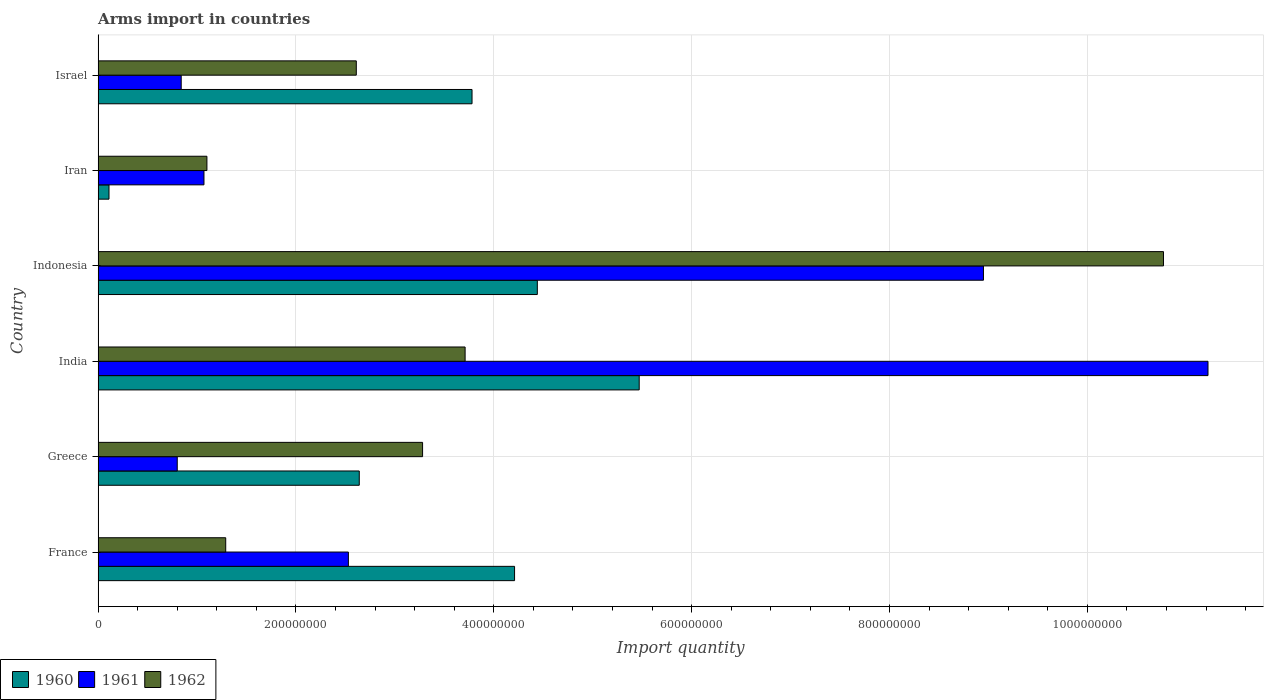How many groups of bars are there?
Offer a terse response. 6. Are the number of bars per tick equal to the number of legend labels?
Offer a very short reply. Yes. Are the number of bars on each tick of the Y-axis equal?
Your answer should be compact. Yes. How many bars are there on the 5th tick from the top?
Offer a very short reply. 3. How many bars are there on the 6th tick from the bottom?
Ensure brevity in your answer.  3. What is the label of the 3rd group of bars from the top?
Make the answer very short. Indonesia. What is the total arms import in 1960 in Israel?
Ensure brevity in your answer.  3.78e+08. Across all countries, what is the maximum total arms import in 1962?
Offer a very short reply. 1.08e+09. Across all countries, what is the minimum total arms import in 1960?
Your answer should be compact. 1.10e+07. In which country was the total arms import in 1960 minimum?
Give a very brief answer. Iran. What is the total total arms import in 1961 in the graph?
Provide a succinct answer. 2.54e+09. What is the difference between the total arms import in 1961 in Greece and that in India?
Ensure brevity in your answer.  -1.04e+09. What is the difference between the total arms import in 1962 in Israel and the total arms import in 1960 in India?
Make the answer very short. -2.86e+08. What is the average total arms import in 1961 per country?
Keep it short and to the point. 4.24e+08. What is the difference between the total arms import in 1960 and total arms import in 1961 in France?
Ensure brevity in your answer.  1.68e+08. In how many countries, is the total arms import in 1961 greater than 960000000 ?
Provide a short and direct response. 1. What is the ratio of the total arms import in 1961 in Greece to that in India?
Give a very brief answer. 0.07. Is the difference between the total arms import in 1960 in France and Israel greater than the difference between the total arms import in 1961 in France and Israel?
Offer a very short reply. No. What is the difference between the highest and the second highest total arms import in 1961?
Provide a short and direct response. 2.27e+08. What is the difference between the highest and the lowest total arms import in 1960?
Give a very brief answer. 5.36e+08. What does the 3rd bar from the top in Iran represents?
Your answer should be very brief. 1960. What does the 3rd bar from the bottom in Greece represents?
Your response must be concise. 1962. Is it the case that in every country, the sum of the total arms import in 1961 and total arms import in 1960 is greater than the total arms import in 1962?
Your answer should be very brief. Yes. How many countries are there in the graph?
Your response must be concise. 6. What is the difference between two consecutive major ticks on the X-axis?
Provide a short and direct response. 2.00e+08. Are the values on the major ticks of X-axis written in scientific E-notation?
Make the answer very short. No. Does the graph contain any zero values?
Ensure brevity in your answer.  No. Where does the legend appear in the graph?
Your answer should be very brief. Bottom left. How many legend labels are there?
Your answer should be compact. 3. How are the legend labels stacked?
Your response must be concise. Horizontal. What is the title of the graph?
Your response must be concise. Arms import in countries. What is the label or title of the X-axis?
Ensure brevity in your answer.  Import quantity. What is the Import quantity in 1960 in France?
Make the answer very short. 4.21e+08. What is the Import quantity in 1961 in France?
Give a very brief answer. 2.53e+08. What is the Import quantity of 1962 in France?
Your response must be concise. 1.29e+08. What is the Import quantity of 1960 in Greece?
Provide a short and direct response. 2.64e+08. What is the Import quantity in 1961 in Greece?
Ensure brevity in your answer.  8.00e+07. What is the Import quantity in 1962 in Greece?
Offer a very short reply. 3.28e+08. What is the Import quantity of 1960 in India?
Your answer should be very brief. 5.47e+08. What is the Import quantity in 1961 in India?
Offer a terse response. 1.12e+09. What is the Import quantity of 1962 in India?
Your response must be concise. 3.71e+08. What is the Import quantity of 1960 in Indonesia?
Ensure brevity in your answer.  4.44e+08. What is the Import quantity in 1961 in Indonesia?
Provide a short and direct response. 8.95e+08. What is the Import quantity of 1962 in Indonesia?
Make the answer very short. 1.08e+09. What is the Import quantity of 1960 in Iran?
Provide a succinct answer. 1.10e+07. What is the Import quantity of 1961 in Iran?
Your answer should be compact. 1.07e+08. What is the Import quantity in 1962 in Iran?
Make the answer very short. 1.10e+08. What is the Import quantity of 1960 in Israel?
Your answer should be very brief. 3.78e+08. What is the Import quantity of 1961 in Israel?
Ensure brevity in your answer.  8.40e+07. What is the Import quantity of 1962 in Israel?
Your answer should be compact. 2.61e+08. Across all countries, what is the maximum Import quantity in 1960?
Ensure brevity in your answer.  5.47e+08. Across all countries, what is the maximum Import quantity in 1961?
Provide a short and direct response. 1.12e+09. Across all countries, what is the maximum Import quantity in 1962?
Your answer should be very brief. 1.08e+09. Across all countries, what is the minimum Import quantity of 1960?
Your answer should be compact. 1.10e+07. Across all countries, what is the minimum Import quantity in 1961?
Give a very brief answer. 8.00e+07. Across all countries, what is the minimum Import quantity of 1962?
Your answer should be very brief. 1.10e+08. What is the total Import quantity in 1960 in the graph?
Your answer should be very brief. 2.06e+09. What is the total Import quantity of 1961 in the graph?
Provide a short and direct response. 2.54e+09. What is the total Import quantity in 1962 in the graph?
Make the answer very short. 2.28e+09. What is the difference between the Import quantity of 1960 in France and that in Greece?
Your response must be concise. 1.57e+08. What is the difference between the Import quantity in 1961 in France and that in Greece?
Offer a terse response. 1.73e+08. What is the difference between the Import quantity in 1962 in France and that in Greece?
Offer a terse response. -1.99e+08. What is the difference between the Import quantity in 1960 in France and that in India?
Keep it short and to the point. -1.26e+08. What is the difference between the Import quantity of 1961 in France and that in India?
Offer a very short reply. -8.69e+08. What is the difference between the Import quantity in 1962 in France and that in India?
Provide a short and direct response. -2.42e+08. What is the difference between the Import quantity in 1960 in France and that in Indonesia?
Provide a succinct answer. -2.30e+07. What is the difference between the Import quantity in 1961 in France and that in Indonesia?
Offer a terse response. -6.42e+08. What is the difference between the Import quantity in 1962 in France and that in Indonesia?
Keep it short and to the point. -9.48e+08. What is the difference between the Import quantity in 1960 in France and that in Iran?
Keep it short and to the point. 4.10e+08. What is the difference between the Import quantity in 1961 in France and that in Iran?
Provide a short and direct response. 1.46e+08. What is the difference between the Import quantity in 1962 in France and that in Iran?
Provide a short and direct response. 1.90e+07. What is the difference between the Import quantity of 1960 in France and that in Israel?
Your answer should be very brief. 4.30e+07. What is the difference between the Import quantity in 1961 in France and that in Israel?
Ensure brevity in your answer.  1.69e+08. What is the difference between the Import quantity in 1962 in France and that in Israel?
Ensure brevity in your answer.  -1.32e+08. What is the difference between the Import quantity in 1960 in Greece and that in India?
Keep it short and to the point. -2.83e+08. What is the difference between the Import quantity of 1961 in Greece and that in India?
Provide a succinct answer. -1.04e+09. What is the difference between the Import quantity of 1962 in Greece and that in India?
Your answer should be compact. -4.30e+07. What is the difference between the Import quantity in 1960 in Greece and that in Indonesia?
Provide a short and direct response. -1.80e+08. What is the difference between the Import quantity in 1961 in Greece and that in Indonesia?
Offer a terse response. -8.15e+08. What is the difference between the Import quantity in 1962 in Greece and that in Indonesia?
Offer a terse response. -7.49e+08. What is the difference between the Import quantity in 1960 in Greece and that in Iran?
Offer a terse response. 2.53e+08. What is the difference between the Import quantity in 1961 in Greece and that in Iran?
Offer a terse response. -2.70e+07. What is the difference between the Import quantity of 1962 in Greece and that in Iran?
Your answer should be very brief. 2.18e+08. What is the difference between the Import quantity in 1960 in Greece and that in Israel?
Keep it short and to the point. -1.14e+08. What is the difference between the Import quantity in 1961 in Greece and that in Israel?
Your response must be concise. -4.00e+06. What is the difference between the Import quantity of 1962 in Greece and that in Israel?
Provide a succinct answer. 6.70e+07. What is the difference between the Import quantity in 1960 in India and that in Indonesia?
Your answer should be compact. 1.03e+08. What is the difference between the Import quantity of 1961 in India and that in Indonesia?
Offer a very short reply. 2.27e+08. What is the difference between the Import quantity in 1962 in India and that in Indonesia?
Provide a succinct answer. -7.06e+08. What is the difference between the Import quantity in 1960 in India and that in Iran?
Your answer should be compact. 5.36e+08. What is the difference between the Import quantity in 1961 in India and that in Iran?
Provide a succinct answer. 1.02e+09. What is the difference between the Import quantity of 1962 in India and that in Iran?
Your response must be concise. 2.61e+08. What is the difference between the Import quantity in 1960 in India and that in Israel?
Offer a very short reply. 1.69e+08. What is the difference between the Import quantity in 1961 in India and that in Israel?
Ensure brevity in your answer.  1.04e+09. What is the difference between the Import quantity of 1962 in India and that in Israel?
Your answer should be very brief. 1.10e+08. What is the difference between the Import quantity of 1960 in Indonesia and that in Iran?
Provide a short and direct response. 4.33e+08. What is the difference between the Import quantity of 1961 in Indonesia and that in Iran?
Provide a succinct answer. 7.88e+08. What is the difference between the Import quantity of 1962 in Indonesia and that in Iran?
Provide a succinct answer. 9.67e+08. What is the difference between the Import quantity in 1960 in Indonesia and that in Israel?
Provide a succinct answer. 6.60e+07. What is the difference between the Import quantity of 1961 in Indonesia and that in Israel?
Provide a short and direct response. 8.11e+08. What is the difference between the Import quantity of 1962 in Indonesia and that in Israel?
Make the answer very short. 8.16e+08. What is the difference between the Import quantity of 1960 in Iran and that in Israel?
Ensure brevity in your answer.  -3.67e+08. What is the difference between the Import quantity in 1961 in Iran and that in Israel?
Your answer should be very brief. 2.30e+07. What is the difference between the Import quantity in 1962 in Iran and that in Israel?
Your answer should be compact. -1.51e+08. What is the difference between the Import quantity in 1960 in France and the Import quantity in 1961 in Greece?
Ensure brevity in your answer.  3.41e+08. What is the difference between the Import quantity in 1960 in France and the Import quantity in 1962 in Greece?
Offer a very short reply. 9.30e+07. What is the difference between the Import quantity of 1961 in France and the Import quantity of 1962 in Greece?
Ensure brevity in your answer.  -7.50e+07. What is the difference between the Import quantity of 1960 in France and the Import quantity of 1961 in India?
Give a very brief answer. -7.01e+08. What is the difference between the Import quantity of 1960 in France and the Import quantity of 1962 in India?
Keep it short and to the point. 5.00e+07. What is the difference between the Import quantity of 1961 in France and the Import quantity of 1962 in India?
Offer a terse response. -1.18e+08. What is the difference between the Import quantity of 1960 in France and the Import quantity of 1961 in Indonesia?
Provide a short and direct response. -4.74e+08. What is the difference between the Import quantity in 1960 in France and the Import quantity in 1962 in Indonesia?
Give a very brief answer. -6.56e+08. What is the difference between the Import quantity of 1961 in France and the Import quantity of 1962 in Indonesia?
Offer a terse response. -8.24e+08. What is the difference between the Import quantity of 1960 in France and the Import quantity of 1961 in Iran?
Provide a short and direct response. 3.14e+08. What is the difference between the Import quantity in 1960 in France and the Import quantity in 1962 in Iran?
Your response must be concise. 3.11e+08. What is the difference between the Import quantity in 1961 in France and the Import quantity in 1962 in Iran?
Your answer should be very brief. 1.43e+08. What is the difference between the Import quantity of 1960 in France and the Import quantity of 1961 in Israel?
Your response must be concise. 3.37e+08. What is the difference between the Import quantity in 1960 in France and the Import quantity in 1962 in Israel?
Your answer should be very brief. 1.60e+08. What is the difference between the Import quantity of 1961 in France and the Import quantity of 1962 in Israel?
Offer a terse response. -8.00e+06. What is the difference between the Import quantity in 1960 in Greece and the Import quantity in 1961 in India?
Give a very brief answer. -8.58e+08. What is the difference between the Import quantity of 1960 in Greece and the Import quantity of 1962 in India?
Keep it short and to the point. -1.07e+08. What is the difference between the Import quantity of 1961 in Greece and the Import quantity of 1962 in India?
Ensure brevity in your answer.  -2.91e+08. What is the difference between the Import quantity in 1960 in Greece and the Import quantity in 1961 in Indonesia?
Keep it short and to the point. -6.31e+08. What is the difference between the Import quantity of 1960 in Greece and the Import quantity of 1962 in Indonesia?
Give a very brief answer. -8.13e+08. What is the difference between the Import quantity in 1961 in Greece and the Import quantity in 1962 in Indonesia?
Provide a short and direct response. -9.97e+08. What is the difference between the Import quantity of 1960 in Greece and the Import quantity of 1961 in Iran?
Provide a succinct answer. 1.57e+08. What is the difference between the Import quantity of 1960 in Greece and the Import quantity of 1962 in Iran?
Your answer should be compact. 1.54e+08. What is the difference between the Import quantity of 1961 in Greece and the Import quantity of 1962 in Iran?
Your answer should be very brief. -3.00e+07. What is the difference between the Import quantity of 1960 in Greece and the Import quantity of 1961 in Israel?
Offer a very short reply. 1.80e+08. What is the difference between the Import quantity in 1961 in Greece and the Import quantity in 1962 in Israel?
Your answer should be compact. -1.81e+08. What is the difference between the Import quantity in 1960 in India and the Import quantity in 1961 in Indonesia?
Provide a succinct answer. -3.48e+08. What is the difference between the Import quantity in 1960 in India and the Import quantity in 1962 in Indonesia?
Keep it short and to the point. -5.30e+08. What is the difference between the Import quantity in 1961 in India and the Import quantity in 1962 in Indonesia?
Provide a short and direct response. 4.50e+07. What is the difference between the Import quantity of 1960 in India and the Import quantity of 1961 in Iran?
Ensure brevity in your answer.  4.40e+08. What is the difference between the Import quantity in 1960 in India and the Import quantity in 1962 in Iran?
Give a very brief answer. 4.37e+08. What is the difference between the Import quantity of 1961 in India and the Import quantity of 1962 in Iran?
Offer a very short reply. 1.01e+09. What is the difference between the Import quantity in 1960 in India and the Import quantity in 1961 in Israel?
Give a very brief answer. 4.63e+08. What is the difference between the Import quantity in 1960 in India and the Import quantity in 1962 in Israel?
Keep it short and to the point. 2.86e+08. What is the difference between the Import quantity in 1961 in India and the Import quantity in 1962 in Israel?
Provide a short and direct response. 8.61e+08. What is the difference between the Import quantity of 1960 in Indonesia and the Import quantity of 1961 in Iran?
Provide a succinct answer. 3.37e+08. What is the difference between the Import quantity in 1960 in Indonesia and the Import quantity in 1962 in Iran?
Ensure brevity in your answer.  3.34e+08. What is the difference between the Import quantity of 1961 in Indonesia and the Import quantity of 1962 in Iran?
Make the answer very short. 7.85e+08. What is the difference between the Import quantity of 1960 in Indonesia and the Import quantity of 1961 in Israel?
Ensure brevity in your answer.  3.60e+08. What is the difference between the Import quantity in 1960 in Indonesia and the Import quantity in 1962 in Israel?
Provide a short and direct response. 1.83e+08. What is the difference between the Import quantity in 1961 in Indonesia and the Import quantity in 1962 in Israel?
Keep it short and to the point. 6.34e+08. What is the difference between the Import quantity in 1960 in Iran and the Import quantity in 1961 in Israel?
Provide a short and direct response. -7.30e+07. What is the difference between the Import quantity in 1960 in Iran and the Import quantity in 1962 in Israel?
Your answer should be very brief. -2.50e+08. What is the difference between the Import quantity in 1961 in Iran and the Import quantity in 1962 in Israel?
Your answer should be compact. -1.54e+08. What is the average Import quantity in 1960 per country?
Your answer should be very brief. 3.44e+08. What is the average Import quantity in 1961 per country?
Ensure brevity in your answer.  4.24e+08. What is the average Import quantity in 1962 per country?
Provide a succinct answer. 3.79e+08. What is the difference between the Import quantity in 1960 and Import quantity in 1961 in France?
Your answer should be very brief. 1.68e+08. What is the difference between the Import quantity of 1960 and Import quantity of 1962 in France?
Make the answer very short. 2.92e+08. What is the difference between the Import quantity in 1961 and Import quantity in 1962 in France?
Offer a terse response. 1.24e+08. What is the difference between the Import quantity in 1960 and Import quantity in 1961 in Greece?
Offer a terse response. 1.84e+08. What is the difference between the Import quantity in 1960 and Import quantity in 1962 in Greece?
Make the answer very short. -6.40e+07. What is the difference between the Import quantity of 1961 and Import quantity of 1962 in Greece?
Give a very brief answer. -2.48e+08. What is the difference between the Import quantity in 1960 and Import quantity in 1961 in India?
Offer a terse response. -5.75e+08. What is the difference between the Import quantity in 1960 and Import quantity in 1962 in India?
Make the answer very short. 1.76e+08. What is the difference between the Import quantity in 1961 and Import quantity in 1962 in India?
Offer a very short reply. 7.51e+08. What is the difference between the Import quantity in 1960 and Import quantity in 1961 in Indonesia?
Make the answer very short. -4.51e+08. What is the difference between the Import quantity of 1960 and Import quantity of 1962 in Indonesia?
Make the answer very short. -6.33e+08. What is the difference between the Import quantity in 1961 and Import quantity in 1962 in Indonesia?
Offer a terse response. -1.82e+08. What is the difference between the Import quantity in 1960 and Import quantity in 1961 in Iran?
Make the answer very short. -9.60e+07. What is the difference between the Import quantity in 1960 and Import quantity in 1962 in Iran?
Make the answer very short. -9.90e+07. What is the difference between the Import quantity of 1961 and Import quantity of 1962 in Iran?
Your answer should be compact. -3.00e+06. What is the difference between the Import quantity in 1960 and Import quantity in 1961 in Israel?
Your answer should be very brief. 2.94e+08. What is the difference between the Import quantity in 1960 and Import quantity in 1962 in Israel?
Ensure brevity in your answer.  1.17e+08. What is the difference between the Import quantity of 1961 and Import quantity of 1962 in Israel?
Provide a short and direct response. -1.77e+08. What is the ratio of the Import quantity of 1960 in France to that in Greece?
Keep it short and to the point. 1.59. What is the ratio of the Import quantity in 1961 in France to that in Greece?
Your answer should be very brief. 3.16. What is the ratio of the Import quantity of 1962 in France to that in Greece?
Offer a terse response. 0.39. What is the ratio of the Import quantity of 1960 in France to that in India?
Provide a succinct answer. 0.77. What is the ratio of the Import quantity of 1961 in France to that in India?
Offer a terse response. 0.23. What is the ratio of the Import quantity of 1962 in France to that in India?
Offer a very short reply. 0.35. What is the ratio of the Import quantity of 1960 in France to that in Indonesia?
Give a very brief answer. 0.95. What is the ratio of the Import quantity of 1961 in France to that in Indonesia?
Your response must be concise. 0.28. What is the ratio of the Import quantity in 1962 in France to that in Indonesia?
Your response must be concise. 0.12. What is the ratio of the Import quantity of 1960 in France to that in Iran?
Your response must be concise. 38.27. What is the ratio of the Import quantity in 1961 in France to that in Iran?
Keep it short and to the point. 2.36. What is the ratio of the Import quantity of 1962 in France to that in Iran?
Make the answer very short. 1.17. What is the ratio of the Import quantity in 1960 in France to that in Israel?
Keep it short and to the point. 1.11. What is the ratio of the Import quantity in 1961 in France to that in Israel?
Provide a short and direct response. 3.01. What is the ratio of the Import quantity of 1962 in France to that in Israel?
Give a very brief answer. 0.49. What is the ratio of the Import quantity in 1960 in Greece to that in India?
Your response must be concise. 0.48. What is the ratio of the Import quantity of 1961 in Greece to that in India?
Offer a terse response. 0.07. What is the ratio of the Import quantity in 1962 in Greece to that in India?
Your response must be concise. 0.88. What is the ratio of the Import quantity in 1960 in Greece to that in Indonesia?
Ensure brevity in your answer.  0.59. What is the ratio of the Import quantity in 1961 in Greece to that in Indonesia?
Provide a succinct answer. 0.09. What is the ratio of the Import quantity of 1962 in Greece to that in Indonesia?
Offer a very short reply. 0.3. What is the ratio of the Import quantity of 1960 in Greece to that in Iran?
Provide a succinct answer. 24. What is the ratio of the Import quantity of 1961 in Greece to that in Iran?
Your answer should be very brief. 0.75. What is the ratio of the Import quantity in 1962 in Greece to that in Iran?
Offer a very short reply. 2.98. What is the ratio of the Import quantity in 1960 in Greece to that in Israel?
Your answer should be very brief. 0.7. What is the ratio of the Import quantity of 1962 in Greece to that in Israel?
Offer a very short reply. 1.26. What is the ratio of the Import quantity in 1960 in India to that in Indonesia?
Give a very brief answer. 1.23. What is the ratio of the Import quantity in 1961 in India to that in Indonesia?
Ensure brevity in your answer.  1.25. What is the ratio of the Import quantity in 1962 in India to that in Indonesia?
Your response must be concise. 0.34. What is the ratio of the Import quantity in 1960 in India to that in Iran?
Provide a succinct answer. 49.73. What is the ratio of the Import quantity in 1961 in India to that in Iran?
Offer a terse response. 10.49. What is the ratio of the Import quantity in 1962 in India to that in Iran?
Offer a terse response. 3.37. What is the ratio of the Import quantity of 1960 in India to that in Israel?
Your answer should be compact. 1.45. What is the ratio of the Import quantity in 1961 in India to that in Israel?
Provide a succinct answer. 13.36. What is the ratio of the Import quantity of 1962 in India to that in Israel?
Make the answer very short. 1.42. What is the ratio of the Import quantity in 1960 in Indonesia to that in Iran?
Ensure brevity in your answer.  40.36. What is the ratio of the Import quantity in 1961 in Indonesia to that in Iran?
Your answer should be very brief. 8.36. What is the ratio of the Import quantity in 1962 in Indonesia to that in Iran?
Your answer should be compact. 9.79. What is the ratio of the Import quantity in 1960 in Indonesia to that in Israel?
Your response must be concise. 1.17. What is the ratio of the Import quantity in 1961 in Indonesia to that in Israel?
Give a very brief answer. 10.65. What is the ratio of the Import quantity of 1962 in Indonesia to that in Israel?
Provide a short and direct response. 4.13. What is the ratio of the Import quantity of 1960 in Iran to that in Israel?
Ensure brevity in your answer.  0.03. What is the ratio of the Import quantity of 1961 in Iran to that in Israel?
Provide a succinct answer. 1.27. What is the ratio of the Import quantity of 1962 in Iran to that in Israel?
Your answer should be very brief. 0.42. What is the difference between the highest and the second highest Import quantity in 1960?
Your answer should be compact. 1.03e+08. What is the difference between the highest and the second highest Import quantity in 1961?
Give a very brief answer. 2.27e+08. What is the difference between the highest and the second highest Import quantity of 1962?
Offer a terse response. 7.06e+08. What is the difference between the highest and the lowest Import quantity in 1960?
Keep it short and to the point. 5.36e+08. What is the difference between the highest and the lowest Import quantity in 1961?
Your response must be concise. 1.04e+09. What is the difference between the highest and the lowest Import quantity in 1962?
Make the answer very short. 9.67e+08. 